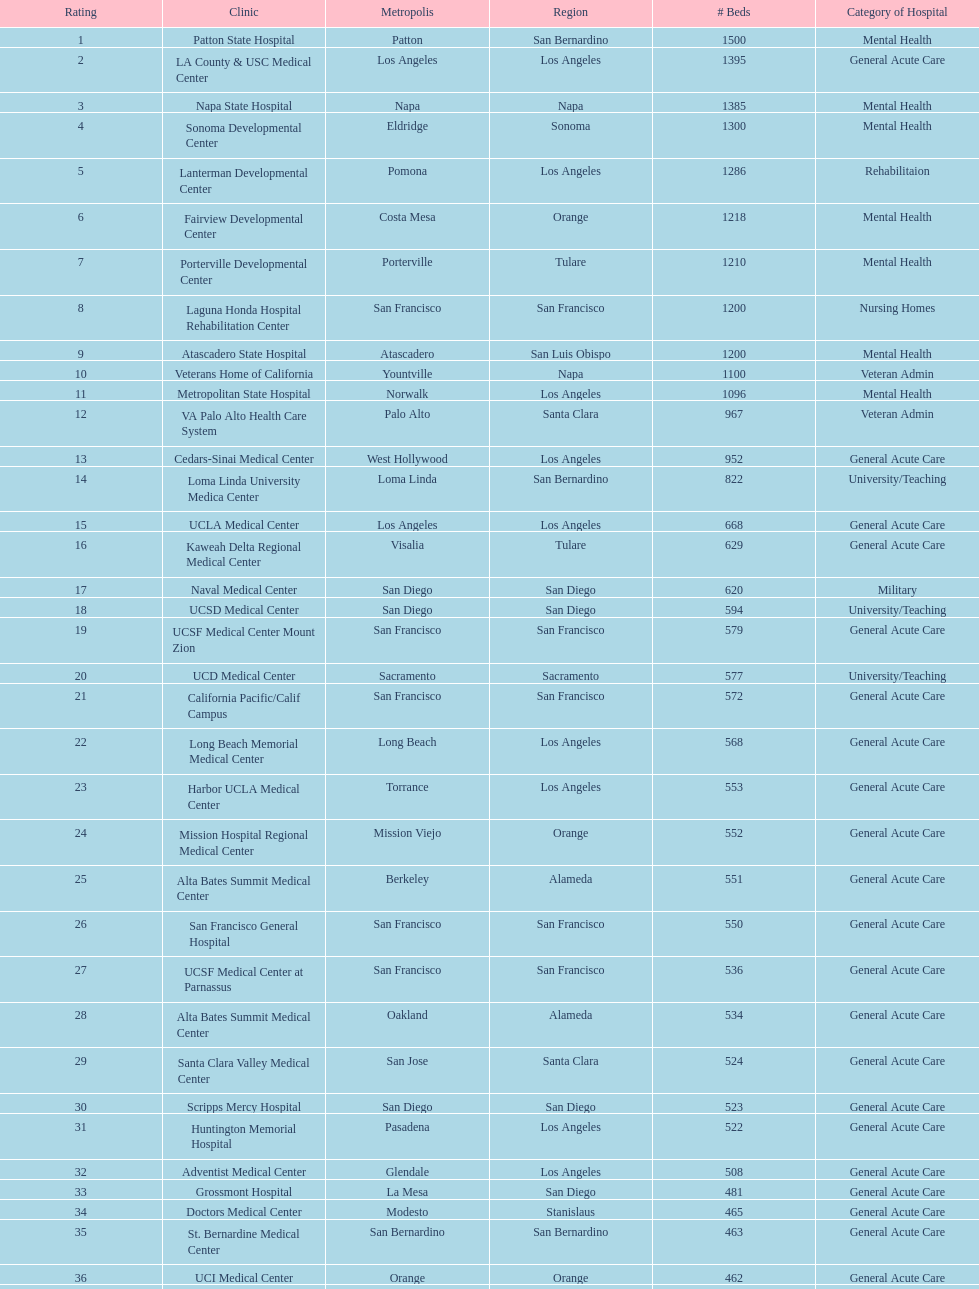Could you parse the entire table? {'header': ['Rating', 'Clinic', 'Metropolis', 'Region', '# Beds', 'Category of Hospital'], 'rows': [['1', 'Patton State Hospital', 'Patton', 'San Bernardino', '1500', 'Mental Health'], ['2', 'LA County & USC Medical Center', 'Los Angeles', 'Los Angeles', '1395', 'General Acute Care'], ['3', 'Napa State Hospital', 'Napa', 'Napa', '1385', 'Mental Health'], ['4', 'Sonoma Developmental Center', 'Eldridge', 'Sonoma', '1300', 'Mental Health'], ['5', 'Lanterman Developmental Center', 'Pomona', 'Los Angeles', '1286', 'Rehabilitaion'], ['6', 'Fairview Developmental Center', 'Costa Mesa', 'Orange', '1218', 'Mental Health'], ['7', 'Porterville Developmental Center', 'Porterville', 'Tulare', '1210', 'Mental Health'], ['8', 'Laguna Honda Hospital Rehabilitation Center', 'San Francisco', 'San Francisco', '1200', 'Nursing Homes'], ['9', 'Atascadero State Hospital', 'Atascadero', 'San Luis Obispo', '1200', 'Mental Health'], ['10', 'Veterans Home of California', 'Yountville', 'Napa', '1100', 'Veteran Admin'], ['11', 'Metropolitan State Hospital', 'Norwalk', 'Los Angeles', '1096', 'Mental Health'], ['12', 'VA Palo Alto Health Care System', 'Palo Alto', 'Santa Clara', '967', 'Veteran Admin'], ['13', 'Cedars-Sinai Medical Center', 'West Hollywood', 'Los Angeles', '952', 'General Acute Care'], ['14', 'Loma Linda University Medica Center', 'Loma Linda', 'San Bernardino', '822', 'University/Teaching'], ['15', 'UCLA Medical Center', 'Los Angeles', 'Los Angeles', '668', 'General Acute Care'], ['16', 'Kaweah Delta Regional Medical Center', 'Visalia', 'Tulare', '629', 'General Acute Care'], ['17', 'Naval Medical Center', 'San Diego', 'San Diego', '620', 'Military'], ['18', 'UCSD Medical Center', 'San Diego', 'San Diego', '594', 'University/Teaching'], ['19', 'UCSF Medical Center Mount Zion', 'San Francisco', 'San Francisco', '579', 'General Acute Care'], ['20', 'UCD Medical Center', 'Sacramento', 'Sacramento', '577', 'University/Teaching'], ['21', 'California Pacific/Calif Campus', 'San Francisco', 'San Francisco', '572', 'General Acute Care'], ['22', 'Long Beach Memorial Medical Center', 'Long Beach', 'Los Angeles', '568', 'General Acute Care'], ['23', 'Harbor UCLA Medical Center', 'Torrance', 'Los Angeles', '553', 'General Acute Care'], ['24', 'Mission Hospital Regional Medical Center', 'Mission Viejo', 'Orange', '552', 'General Acute Care'], ['25', 'Alta Bates Summit Medical Center', 'Berkeley', 'Alameda', '551', 'General Acute Care'], ['26', 'San Francisco General Hospital', 'San Francisco', 'San Francisco', '550', 'General Acute Care'], ['27', 'UCSF Medical Center at Parnassus', 'San Francisco', 'San Francisco', '536', 'General Acute Care'], ['28', 'Alta Bates Summit Medical Center', 'Oakland', 'Alameda', '534', 'General Acute Care'], ['29', 'Santa Clara Valley Medical Center', 'San Jose', 'Santa Clara', '524', 'General Acute Care'], ['30', 'Scripps Mercy Hospital', 'San Diego', 'San Diego', '523', 'General Acute Care'], ['31', 'Huntington Memorial Hospital', 'Pasadena', 'Los Angeles', '522', 'General Acute Care'], ['32', 'Adventist Medical Center', 'Glendale', 'Los Angeles', '508', 'General Acute Care'], ['33', 'Grossmont Hospital', 'La Mesa', 'San Diego', '481', 'General Acute Care'], ['34', 'Doctors Medical Center', 'Modesto', 'Stanislaus', '465', 'General Acute Care'], ['35', 'St. Bernardine Medical Center', 'San Bernardino', 'San Bernardino', '463', 'General Acute Care'], ['36', 'UCI Medical Center', 'Orange', 'Orange', '462', 'General Acute Care'], ['37', 'Stanford Medical Center', 'Stanford', 'Santa Clara', '460', 'General Acute Care'], ['38', 'Community Regional Medical Center', 'Fresno', 'Fresno', '457', 'General Acute Care'], ['39', 'Methodist Hospital', 'Arcadia', 'Los Angeles', '455', 'General Acute Care'], ['40', 'Providence St. Joseph Medical Center', 'Burbank', 'Los Angeles', '455', 'General Acute Care'], ['41', 'Hoag Memorial Hospital', 'Newport Beach', 'Orange', '450', 'General Acute Care'], ['42', 'Agnews Developmental Center', 'San Jose', 'Santa Clara', '450', 'Mental Health'], ['43', 'Jewish Home', 'San Francisco', 'San Francisco', '450', 'Nursing Homes'], ['44', 'St. Joseph Hospital Orange', 'Orange', 'Orange', '448', 'General Acute Care'], ['45', 'Presbyterian Intercommunity', 'Whittier', 'Los Angeles', '441', 'General Acute Care'], ['46', 'Kaiser Permanente Medical Center', 'Fontana', 'San Bernardino', '440', 'General Acute Care'], ['47', 'Kaiser Permanente Medical Center', 'Los Angeles', 'Los Angeles', '439', 'General Acute Care'], ['48', 'Pomona Valley Hospital Medical Center', 'Pomona', 'Los Angeles', '436', 'General Acute Care'], ['49', 'Sutter General Medical Center', 'Sacramento', 'Sacramento', '432', 'General Acute Care'], ['50', 'St. Mary Medical Center', 'San Francisco', 'San Francisco', '430', 'General Acute Care'], ['50', 'Good Samaritan Hospital', 'San Jose', 'Santa Clara', '429', 'General Acute Care']]} How many hospital's have at least 600 beds? 17. 